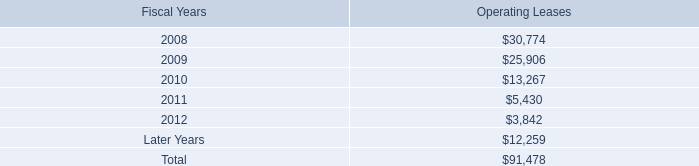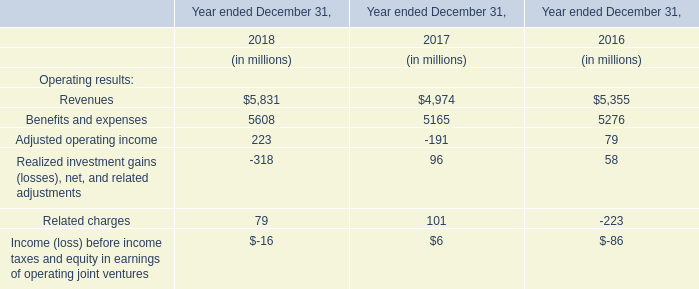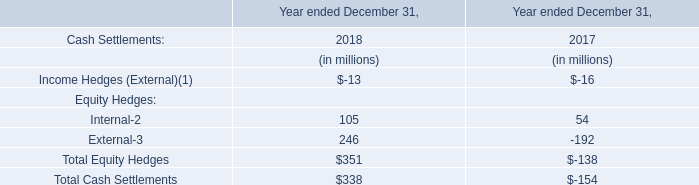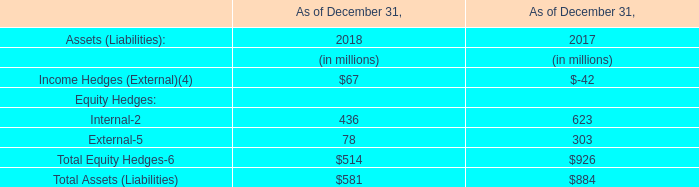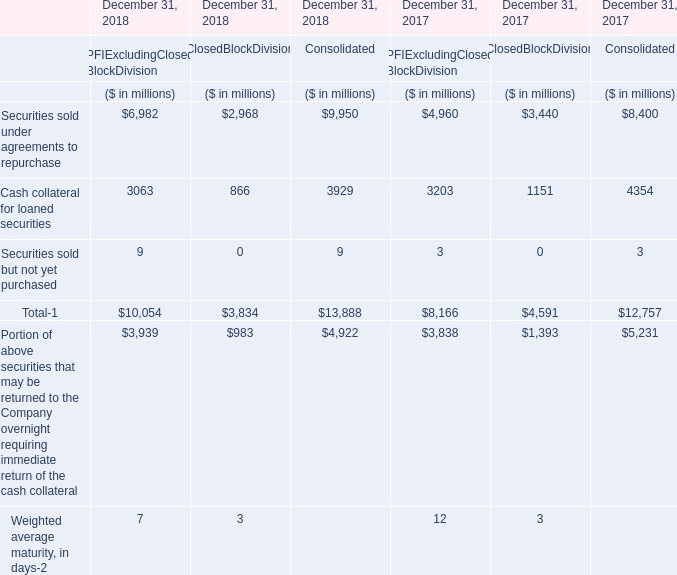what is the growth rate in rental expense under operating leases in 2007? 
Computations: ((43 - 45) / 45)
Answer: -0.04444. 